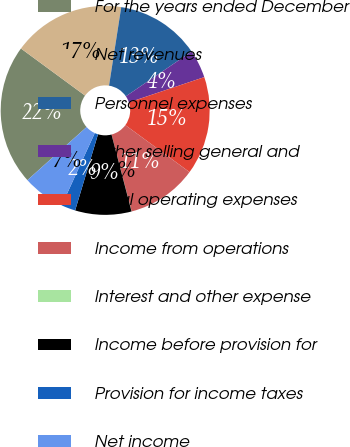Convert chart. <chart><loc_0><loc_0><loc_500><loc_500><pie_chart><fcel>For the years ended December<fcel>Net revenues<fcel>Personnel expenses<fcel>Other selling general and<fcel>Total operating expenses<fcel>Income from operations<fcel>Interest and other expense<fcel>Income before provision for<fcel>Provision for income taxes<fcel>Net income<nl><fcel>21.72%<fcel>17.38%<fcel>13.04%<fcel>4.36%<fcel>15.21%<fcel>10.87%<fcel>0.02%<fcel>8.7%<fcel>2.19%<fcel>6.53%<nl></chart> 